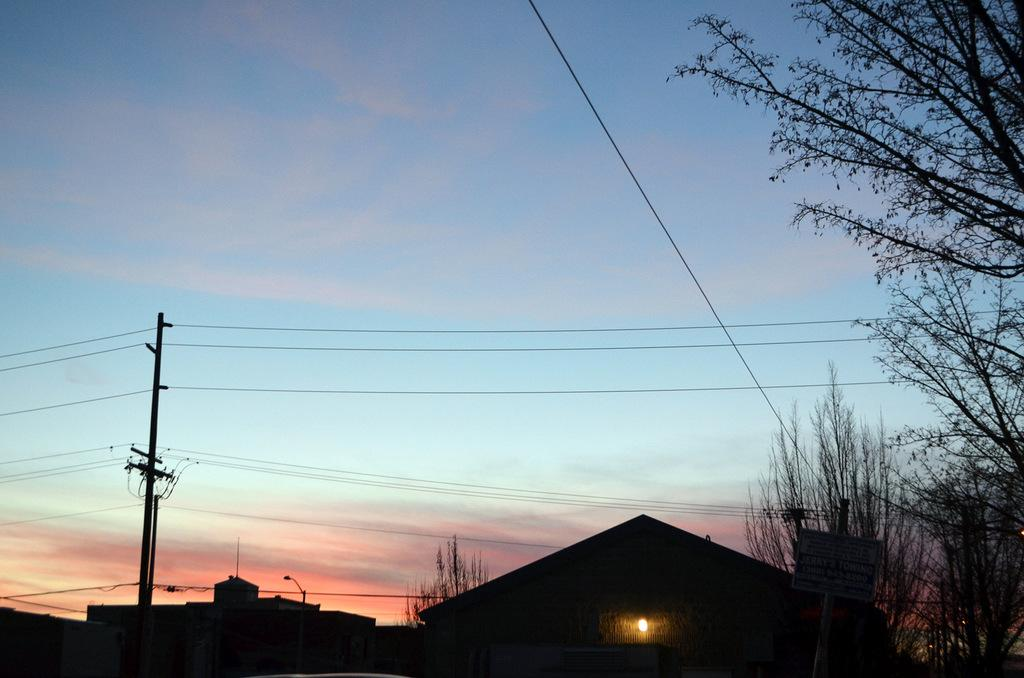What type of structures can be seen in the image? There are houses in the image. What other objects can be seen in the image besides the houses? There is an electrical pole and trees in the image. What color is the sky in the background of the image? The sky is blue in the background of the image. Are there any plastic worms visible in the image? There are no worms, plastic or otherwise, visible in the image. 